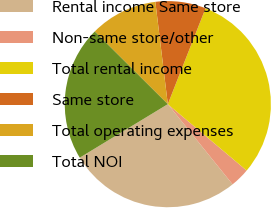Convert chart. <chart><loc_0><loc_0><loc_500><loc_500><pie_chart><fcel>Rental income Same store<fcel>Non-same store/other<fcel>Total rental income<fcel>Same store<fcel>Total operating expenses<fcel>Total NOI<nl><fcel>27.12%<fcel>3.05%<fcel>30.17%<fcel>7.9%<fcel>10.61%<fcel>21.15%<nl></chart> 